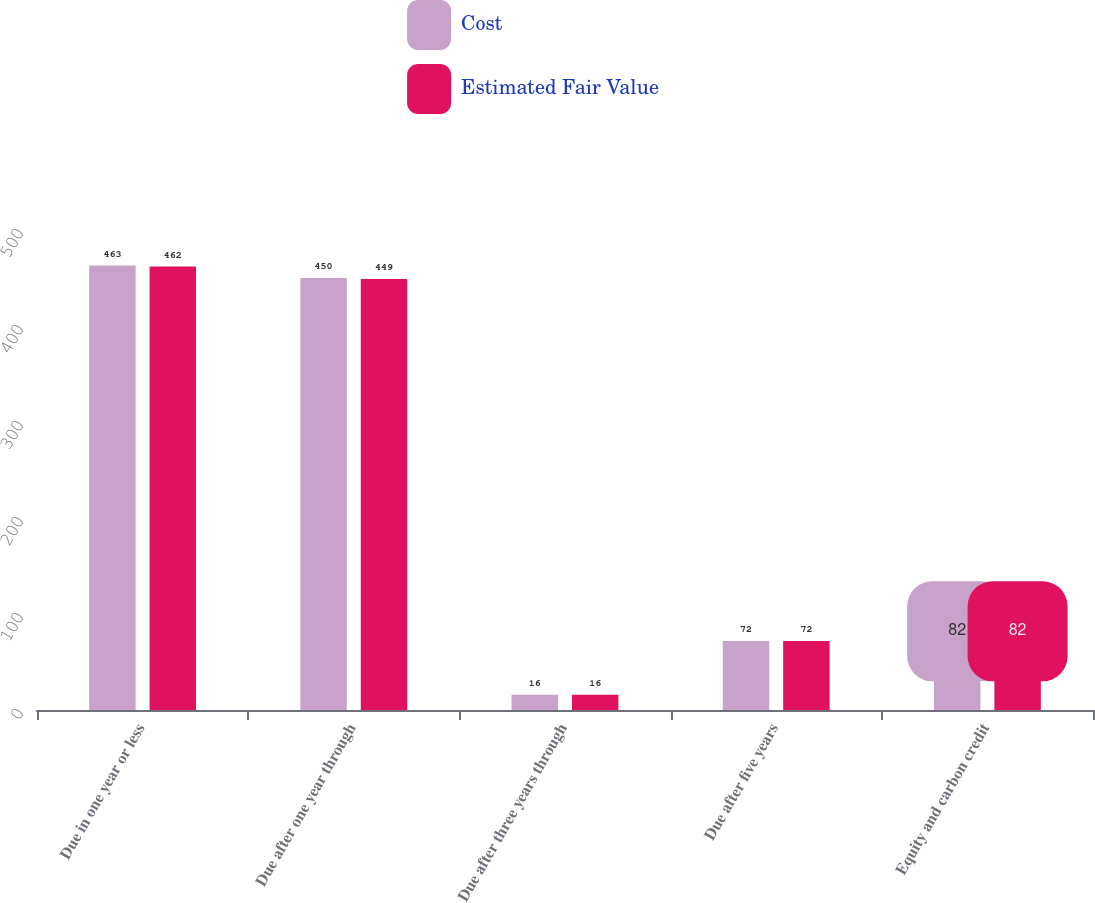Convert chart. <chart><loc_0><loc_0><loc_500><loc_500><stacked_bar_chart><ecel><fcel>Due in one year or less<fcel>Due after one year through<fcel>Due after three years through<fcel>Due after five years<fcel>Equity and carbon credit<nl><fcel>Cost<fcel>463<fcel>450<fcel>16<fcel>72<fcel>82<nl><fcel>Estimated Fair Value<fcel>462<fcel>449<fcel>16<fcel>72<fcel>92<nl></chart> 